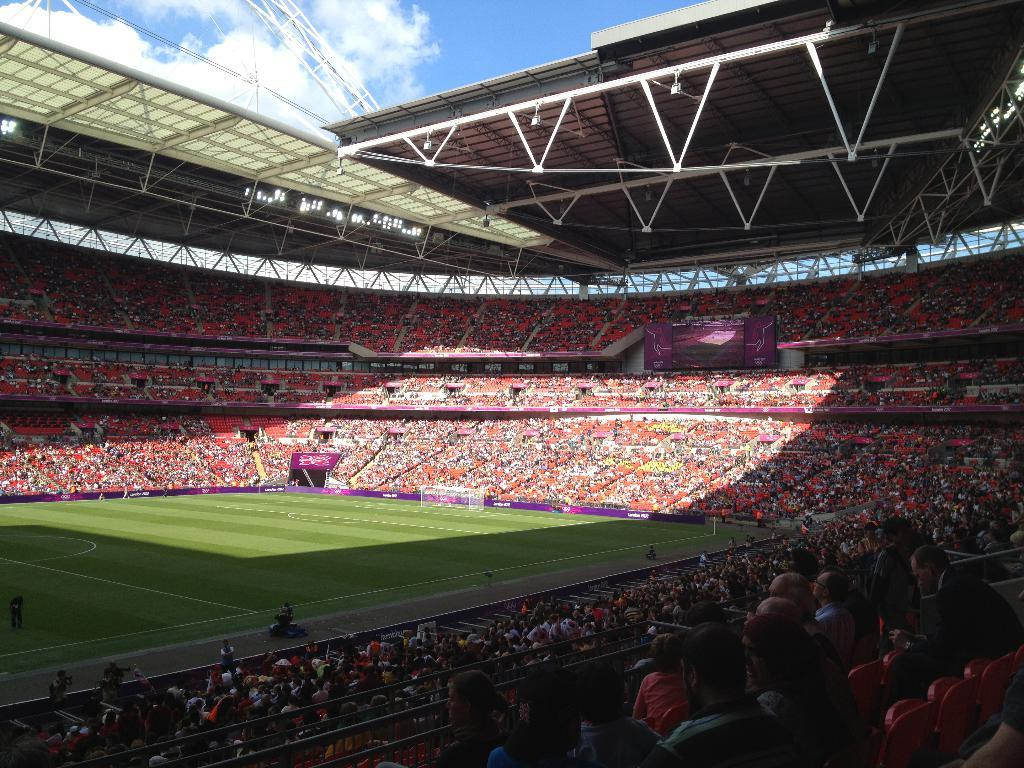What is the main structure in the image? There is a stadium in the image. Where are the people located in the image? There is a group of people sitting on chairs under a roof in the image. What can be seen supporting the roof in the image? There are poles visible in the image. What is visible in the background of the image? The sky is visible in the image. How would you describe the weather based on the sky in the image? The sky appears to be cloudy in the image. How much friction is present between the chairs and the ground in the image? There is no information provided about the friction between the chairs and the ground in the image. 